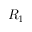<formula> <loc_0><loc_0><loc_500><loc_500>R _ { 1 }</formula> 